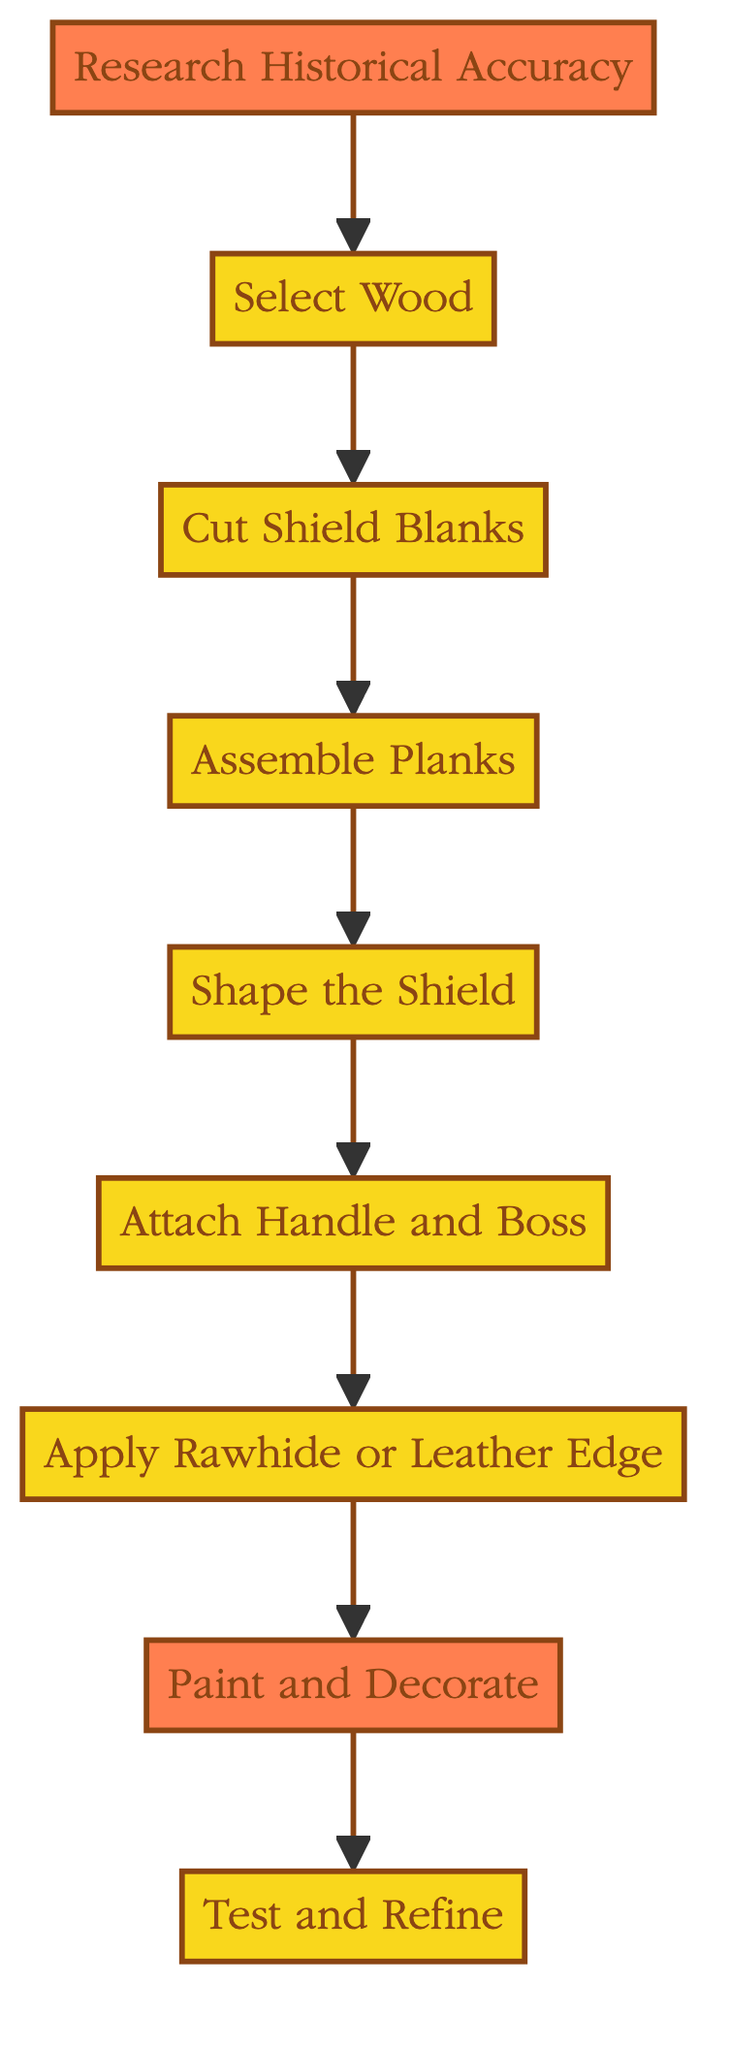What is the first step in recreating a Viking shield? The first step in the flowchart is labeled "Research Historical Accuracy," indicating that this is where the process begins.
Answer: Research Historical Accuracy How many total steps are in the shield recreation process? Counting each node from the diagram, there are a total of nine steps provided in the sequence from "Research Historical Accuracy" to "Test and Refine."
Answer: Nine What step comes immediately after 'Select Wood'? Following the flow from "Select Wood," the next step that follows is "Cut Shield Blanks," which is directly connected to it in the diagram.
Answer: Cut Shield Blanks Which step is highlighted at the end of the process? In the diagram, the last step "Test and Refine" is highlighted, indicating its significance in the overall instruction sequence.
Answer: Test and Refine What is the penultimate step before painting and decorating? The step before "Paint and Decorate" is "Apply Rawhide or Leather Edge," as shown in the flowchart, leading directly to the painting step.
Answer: Apply Rawhide or Leather Edge Which step involves shaping the shield? The diagram clearly specifies the step "Shape the Shield," which follows the assembly of the planks and precedes the attachment of the handle and boss.
Answer: Shape the Shield What materials are mentioned for the edge reinforcement? The step labeled "Apply Rawhide or Leather Edge" cites the use of rawhide or leather strips to reinforce the shield's edge.
Answer: Rawhide or leather What important aspect does 'Research Historical Accuracy' emphasize? This step emphasizes the importance of studying historical sources on Viking shield designs to ensure authenticity in the recreation process.
Answer: Authenticity What do you do after 'Assemble Planks'? After "Assemble Planks", the next action according to the diagram is "Shape the Shield", leading to the surfacing step in the recreation process.
Answer: Shape the Shield 